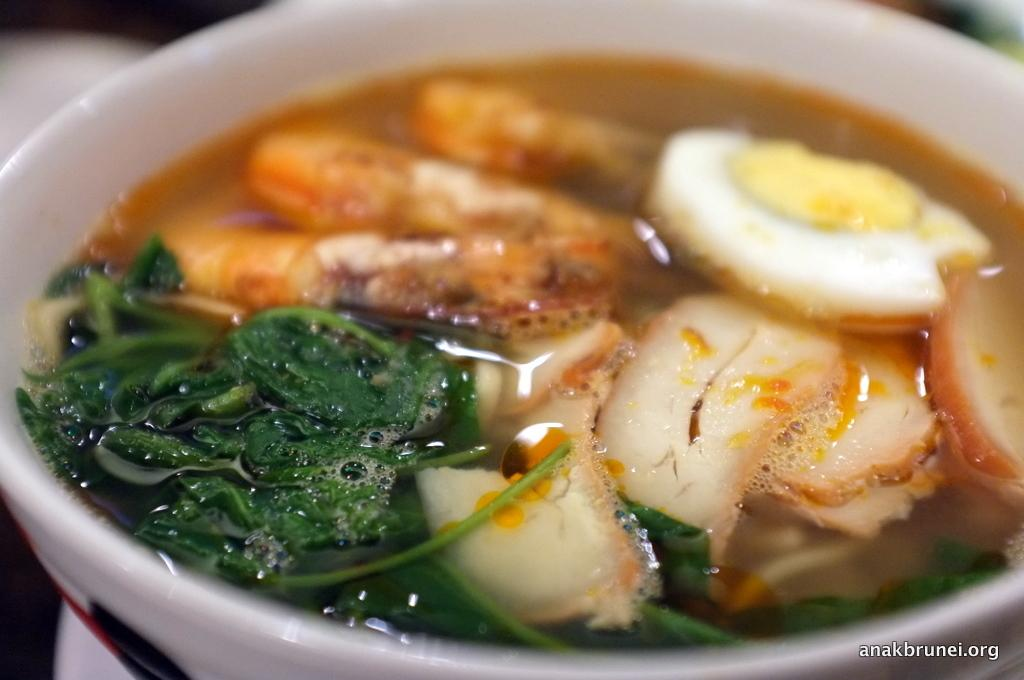What is in the bowl that is visible in the image? There is a bowl with food in the image. Can you describe the background of the image? The background of the image is blurry. Is there any text present in the image? Yes, there is some text in the bottom right corner of the image. What type of seed is being used in the chess game in the image? There is no chess game or seed present in the image. 